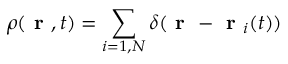Convert formula to latex. <formula><loc_0><loc_0><loc_500><loc_500>\rho ( r , t ) = \sum _ { i = 1 , N } \delta ( r - r _ { i } ( t ) )</formula> 